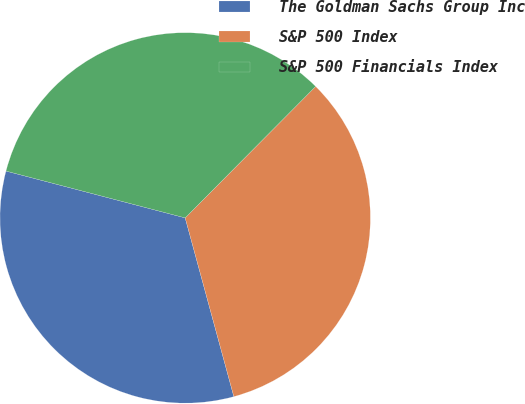Convert chart. <chart><loc_0><loc_0><loc_500><loc_500><pie_chart><fcel>The Goldman Sachs Group Inc<fcel>S&P 500 Index<fcel>S&P 500 Financials Index<nl><fcel>33.3%<fcel>33.33%<fcel>33.37%<nl></chart> 